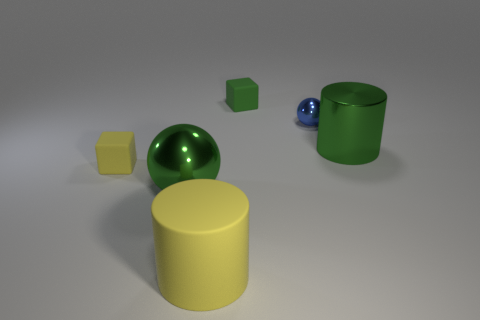What shape is the large shiny thing behind the green metal sphere?
Give a very brief answer. Cylinder. The big cylinder that is the same material as the large sphere is what color?
Offer a terse response. Green. What is the material of the yellow thing that is the same shape as the green rubber object?
Your answer should be very brief. Rubber. What is the shape of the blue metal object?
Offer a very short reply. Sphere. There is a object that is both to the right of the large metal sphere and to the left of the green block; what is it made of?
Your answer should be very brief. Rubber. The big thing that is made of the same material as the tiny green object is what shape?
Your answer should be very brief. Cylinder. There is another green ball that is the same material as the small ball; what is its size?
Provide a short and direct response. Large. What shape is the matte object that is both to the right of the yellow block and in front of the small blue metal sphere?
Your answer should be very brief. Cylinder. There is a yellow matte object to the right of the sphere that is left of the tiny green thing; what size is it?
Provide a succinct answer. Large. How many other objects are there of the same color as the big metal cylinder?
Your answer should be compact. 2. 